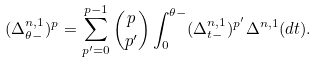<formula> <loc_0><loc_0><loc_500><loc_500>( \Delta ^ { n , 1 } _ { \theta - } ) ^ { p } = \sum _ { p ^ { \prime } = 0 } ^ { p - 1 } \binom { p } { p ^ { \prime } } \int _ { 0 } ^ { \theta - } ( \Delta ^ { n , 1 } _ { t - } ) ^ { p ^ { \prime } } \Delta ^ { n , 1 } ( d t ) .</formula> 